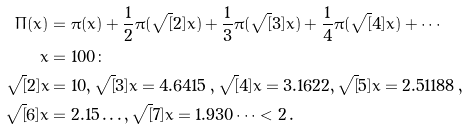<formula> <loc_0><loc_0><loc_500><loc_500>\Pi ( x ) & = \pi ( x ) + \frac { 1 } { 2 } \pi ( \sqrt { [ } 2 ] { x } ) + \frac { 1 } { 3 } \pi ( \sqrt { [ } 3 ] { x } ) + \frac { 1 } { 4 } \pi ( \sqrt { [ } 4 ] { x } ) + \cdots \\ x & = 1 0 0 \colon \\ \sqrt { [ } 2 ] { x } & = 1 0 , \sqrt { [ } 3 ] { x } = 4 . 6 4 1 5 \, , \sqrt { [ } 4 ] { x } = 3 . 1 6 2 2 , \sqrt { [ } 5 ] { x } = 2 . 5 1 1 8 8 \, , \\ \sqrt { [ } 6 ] { x } & = 2 . 1 5 \dots , \sqrt { [ } 7 ] { x } = 1 . 9 3 0 \dots < 2 \, .</formula> 